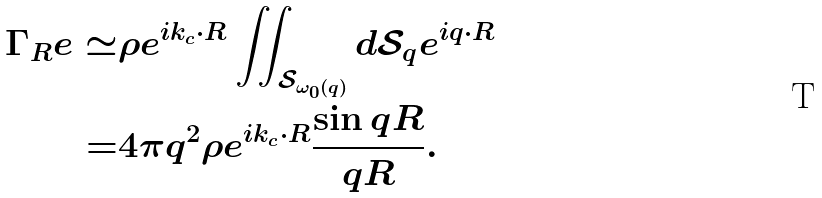Convert formula to latex. <formula><loc_0><loc_0><loc_500><loc_500>\Gamma _ { R } e \simeq & \rho e ^ { i k _ { c } \cdot R } \iint _ { \mathcal { S } _ { \omega _ { 0 } \left ( q \right ) } } d \mathcal { S } _ { q } e ^ { i q \cdot R } \\ = & 4 \pi q ^ { 2 } \rho e ^ { i k _ { c } \cdot R } \frac { \sin { q R } } { q R } .</formula> 